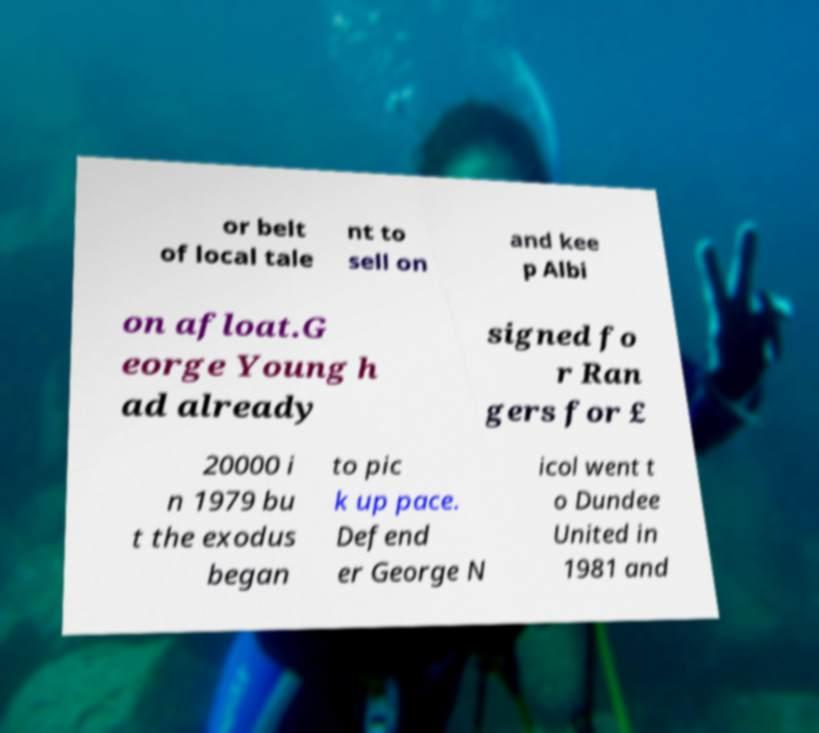I need the written content from this picture converted into text. Can you do that? or belt of local tale nt to sell on and kee p Albi on afloat.G eorge Young h ad already signed fo r Ran gers for £ 20000 i n 1979 bu t the exodus began to pic k up pace. Defend er George N icol went t o Dundee United in 1981 and 